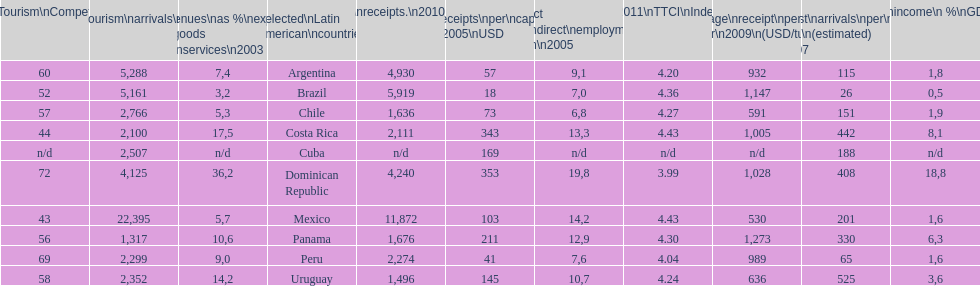What country had the most receipts per capita in 2005? Dominican Republic. 